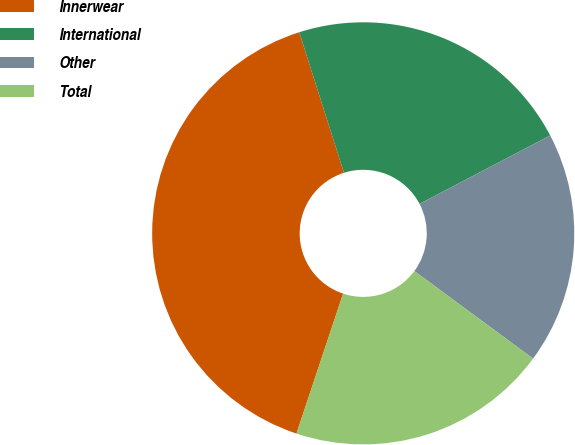Convert chart to OTSL. <chart><loc_0><loc_0><loc_500><loc_500><pie_chart><fcel>Innerwear<fcel>International<fcel>Other<fcel>Total<nl><fcel>39.98%<fcel>22.23%<fcel>17.79%<fcel>20.01%<nl></chart> 